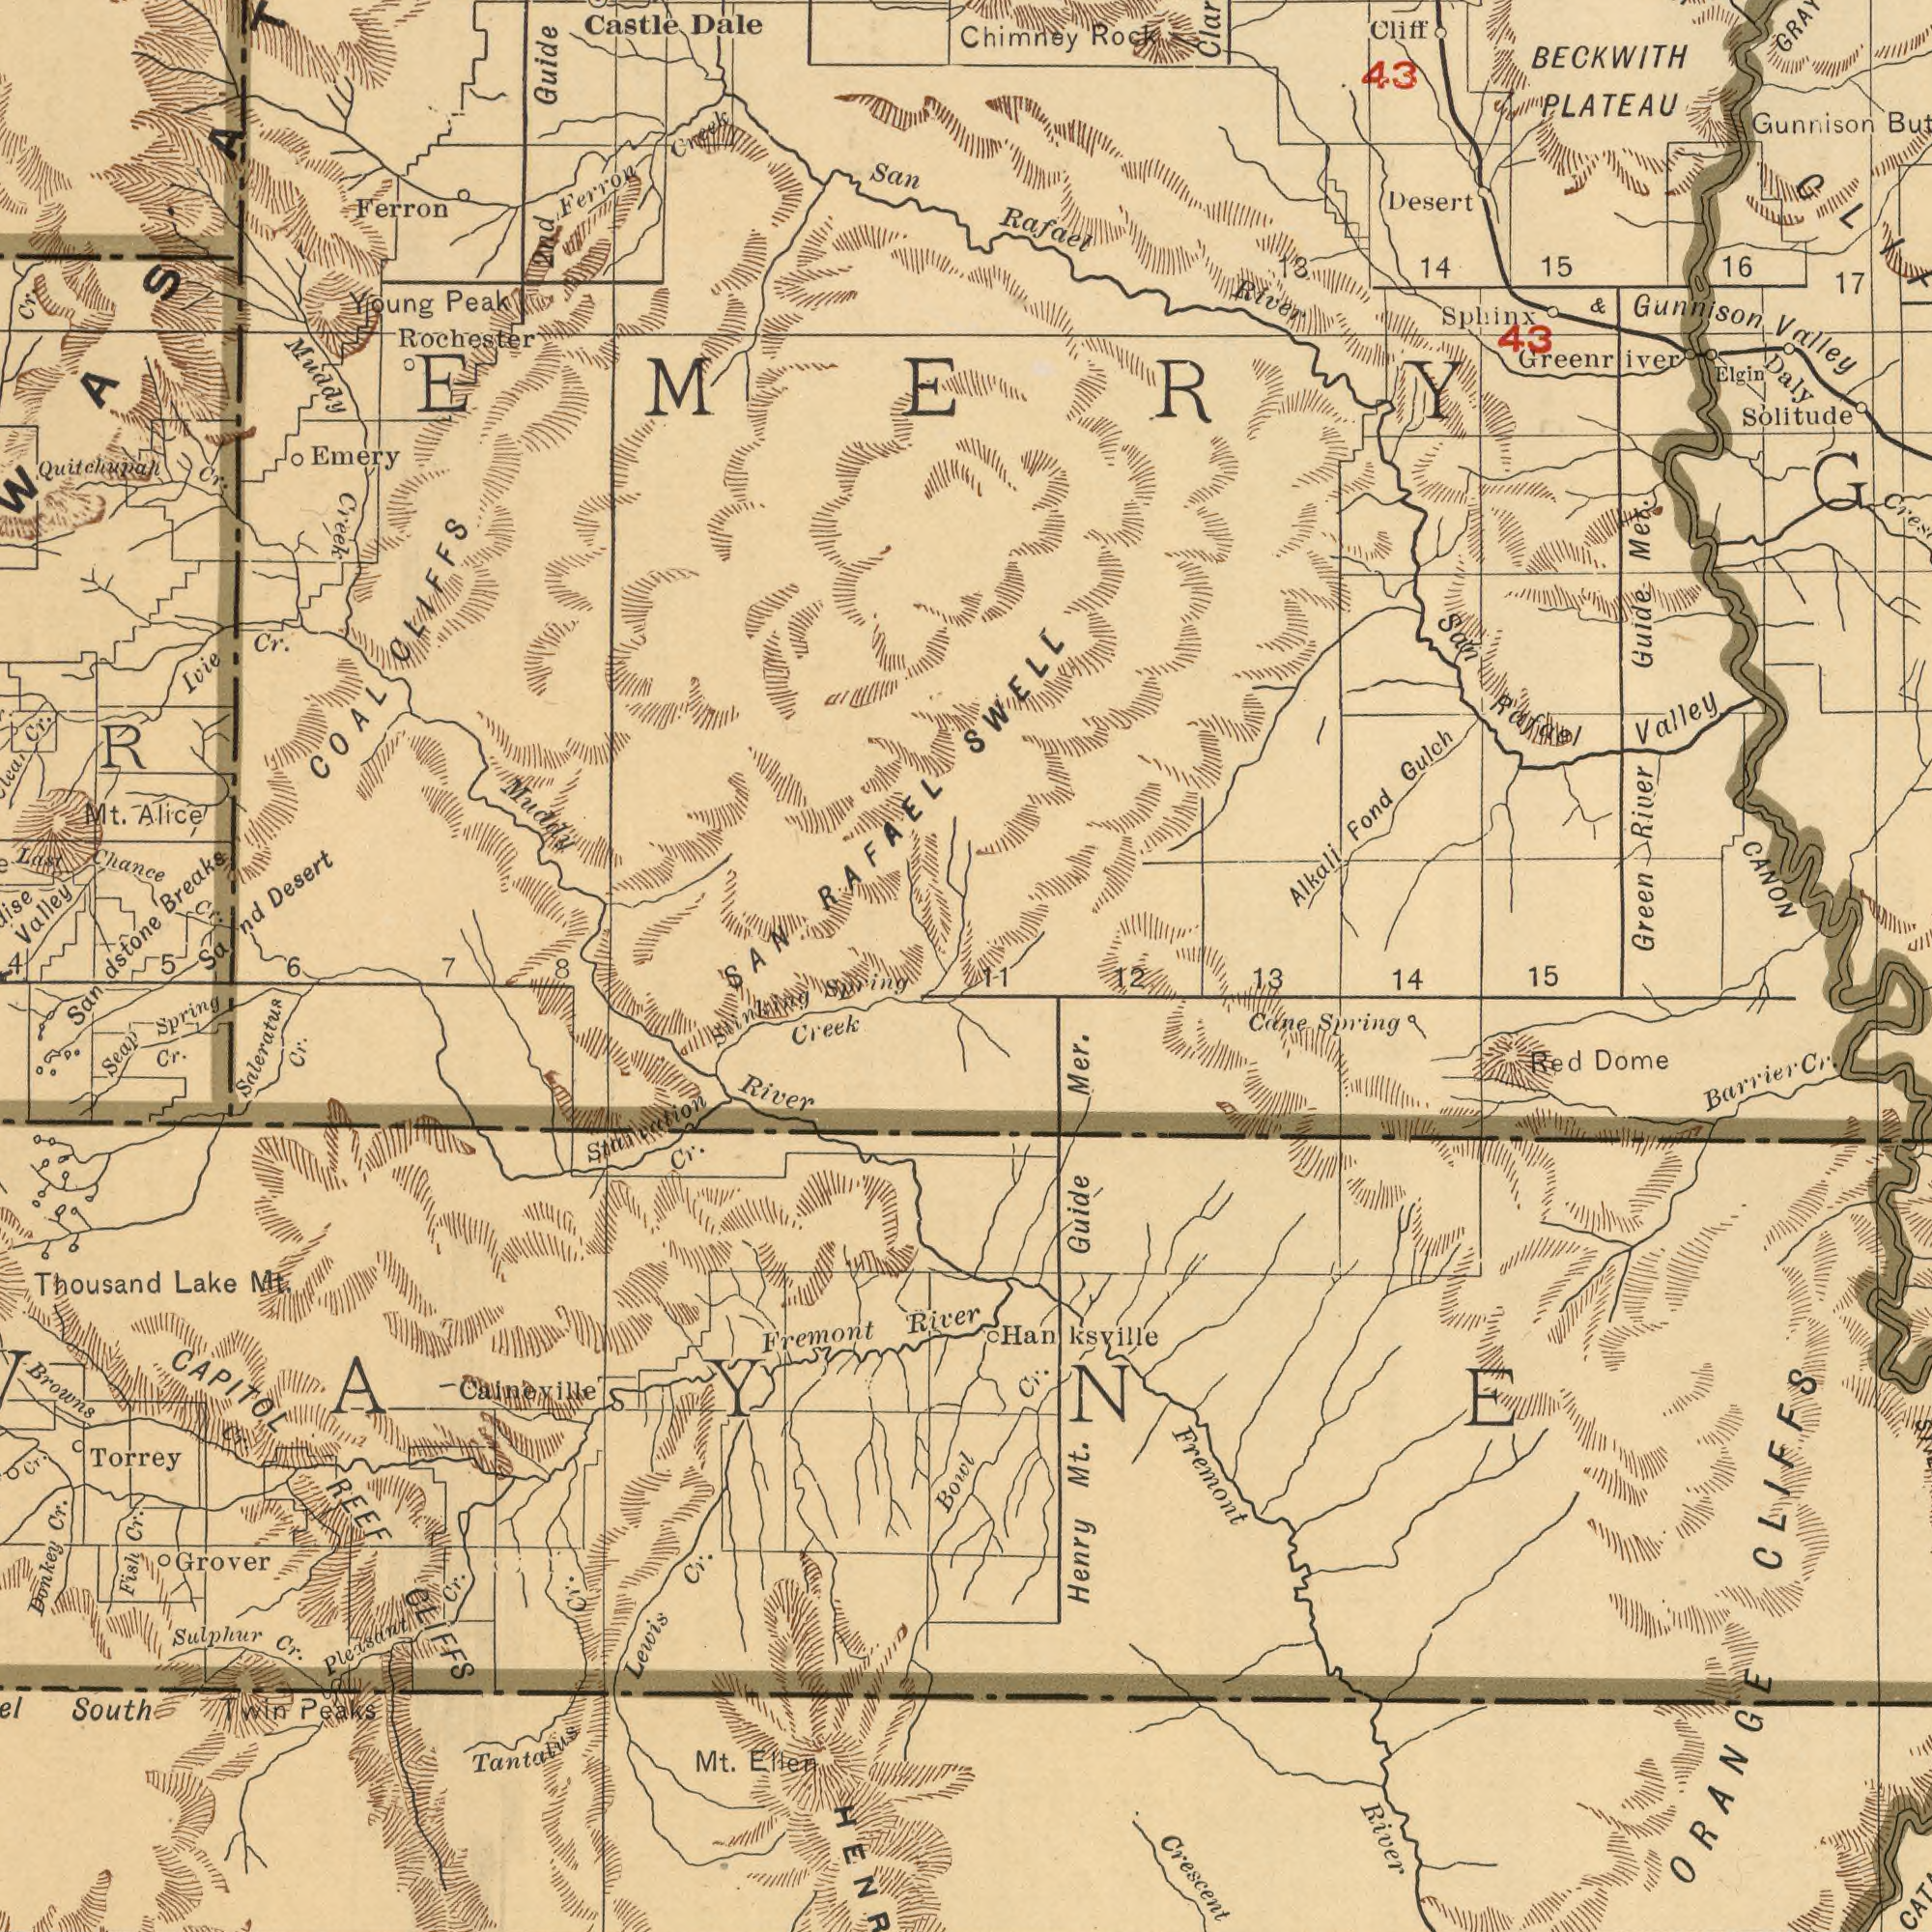What text appears in the bottom-right area of the image? Bowl River Fremont Henry River Spring Barrier Crescent Hanksville Dome Guide Red Cane Mt. 14 Cr. 13 Mer. Cr. 12 CLIFFS 11 15 ORANGE What text is shown in the bottom-left quadrant? CLIFFS REEF Thousand Fremont Browns River Tantalus Caineville Creek Grover Sulphur Lewis Torrey Cr. Cr. Seap Lake Cr. Cr. Cr. Cr. Mt. Donkey South Cr. Cr. Cr. Spring Mt. Peaks Ellen Cr. Fish Pleasant CAPITOL Cr. Spring Saleratus Twin Stinking 8 What text appears in the top-left area of the image? Rochester Valley Desert Dale Chance Creek Alice COAL Ivie Creek Breaks CLIFFS Muddy Guide Ferron Mt. Muddy Peak Cr. San Ferron Castle Cr. ###R 2nd RAFAEL Emery Cr. Sand Last Young Cr. Cr. Quitchupah Sandstone SAN 5 4 EMERY 6 7 What text appears in the top-right area of the image? BECKWITH Gunnison Guide Chimney Desert Solitude River Valley Gunnison PLATEAU Green Elgin River Fond Alkali Gulch 43 Sphinx 14 Rafael 43 15 San Daly Cliff 17 CANON 16 & SWELL Rock Greenriver Rafael Met. Valley 13 